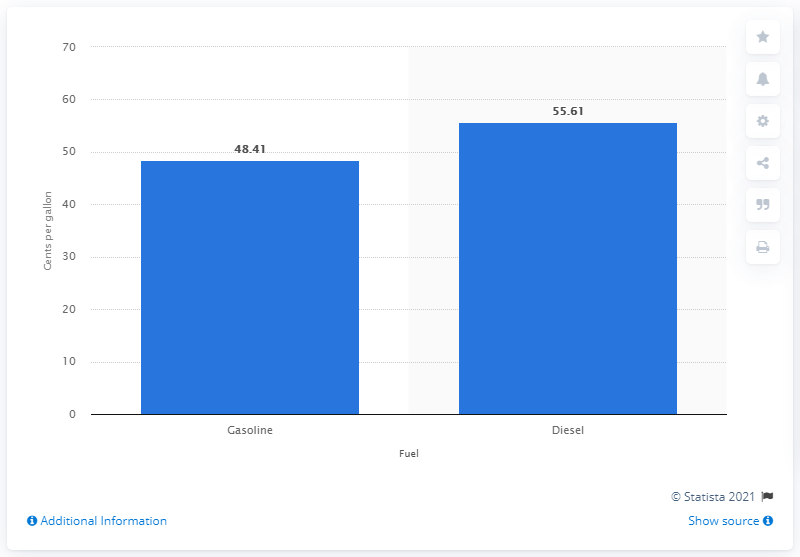Specify some key components in this picture. In October 2017, the state of Maine taxed 48.41 cents per gallon of fuel. 